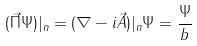Convert formula to latex. <formula><loc_0><loc_0><loc_500><loc_500>( \vec { \Pi } \Psi ) | _ { n } = ( \nabla - i \vec { A } ) | _ { n } \Psi = \frac { \Psi } { b }</formula> 